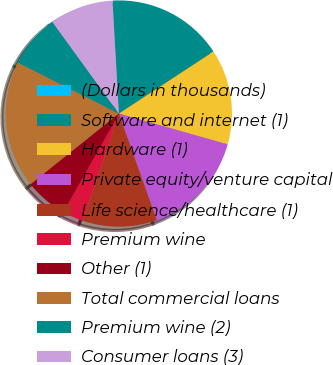<chart> <loc_0><loc_0><loc_500><loc_500><pie_chart><fcel>(Dollars in thousands)<fcel>Software and internet (1)<fcel>Hardware (1)<fcel>Private equity/venture capital<fcel>Life science/healthcare (1)<fcel>Premium wine<fcel>Other (1)<fcel>Total commercial loans<fcel>Premium wine (2)<fcel>Consumer loans (3)<nl><fcel>0.0%<fcel>16.66%<fcel>13.64%<fcel>15.15%<fcel>10.61%<fcel>3.03%<fcel>6.06%<fcel>18.18%<fcel>7.58%<fcel>9.09%<nl></chart> 